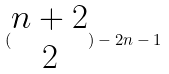<formula> <loc_0><loc_0><loc_500><loc_500>( \begin{matrix} n + 2 \\ 2 \end{matrix} ) - 2 n - 1</formula> 